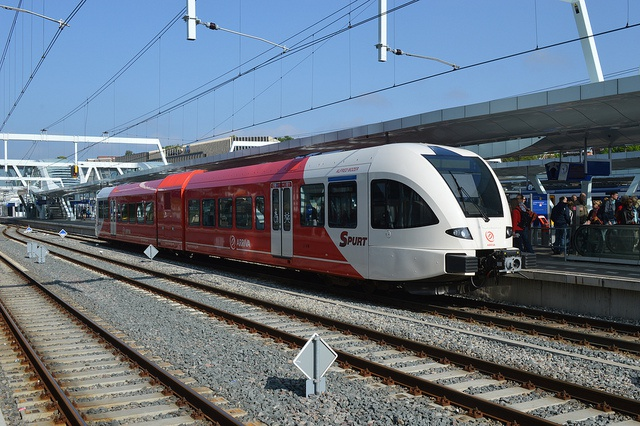Describe the objects in this image and their specific colors. I can see train in darkgray, black, maroon, gray, and lightgray tones, people in darkgray, black, navy, and gray tones, people in darkgray, black, maroon, and gray tones, people in darkgray, black, maroon, and gray tones, and people in darkgray, black, gray, and darkgreen tones in this image. 